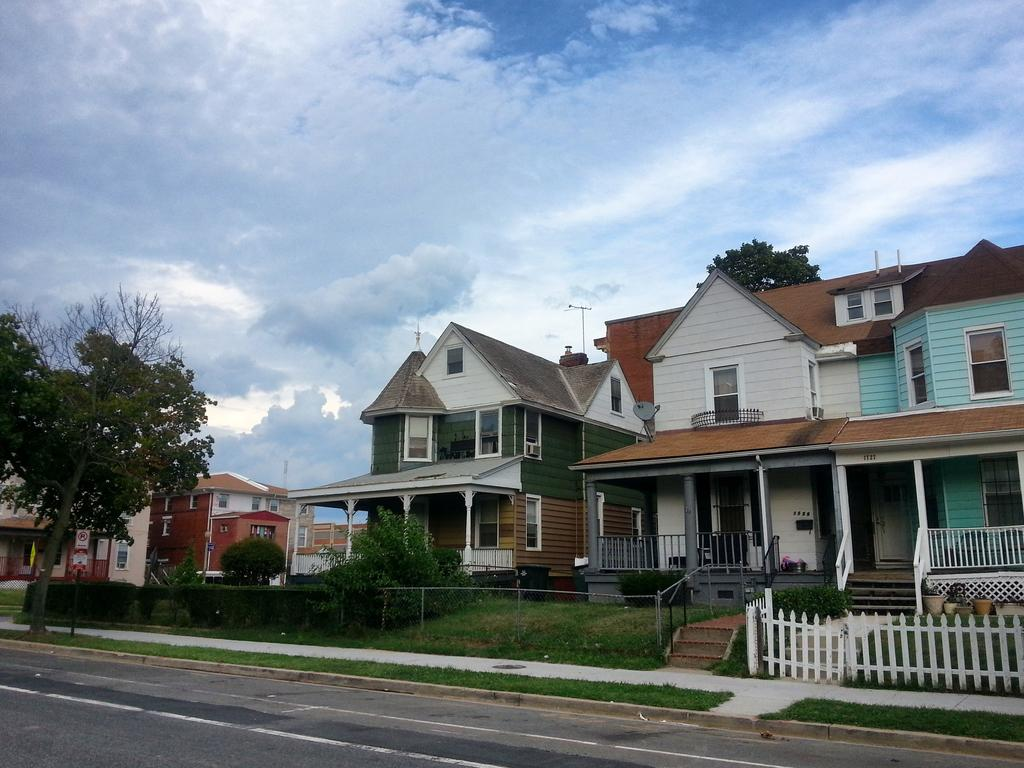What type of structures are visible in the image? There are houses in the image. What can be seen in front of the houses? Trees, hedges, fences, and pots are present in front of the houses. What is located behind the houses? There is a pole behind the houses. What is the condition of the sky in the image? The sky is visible and appears to be cloudy. What type of crime is being committed in the image? There is no indication of any crime being committed in the image. What kind of cheese can be seen on the roof of the houses? There is no cheese present in the image. 